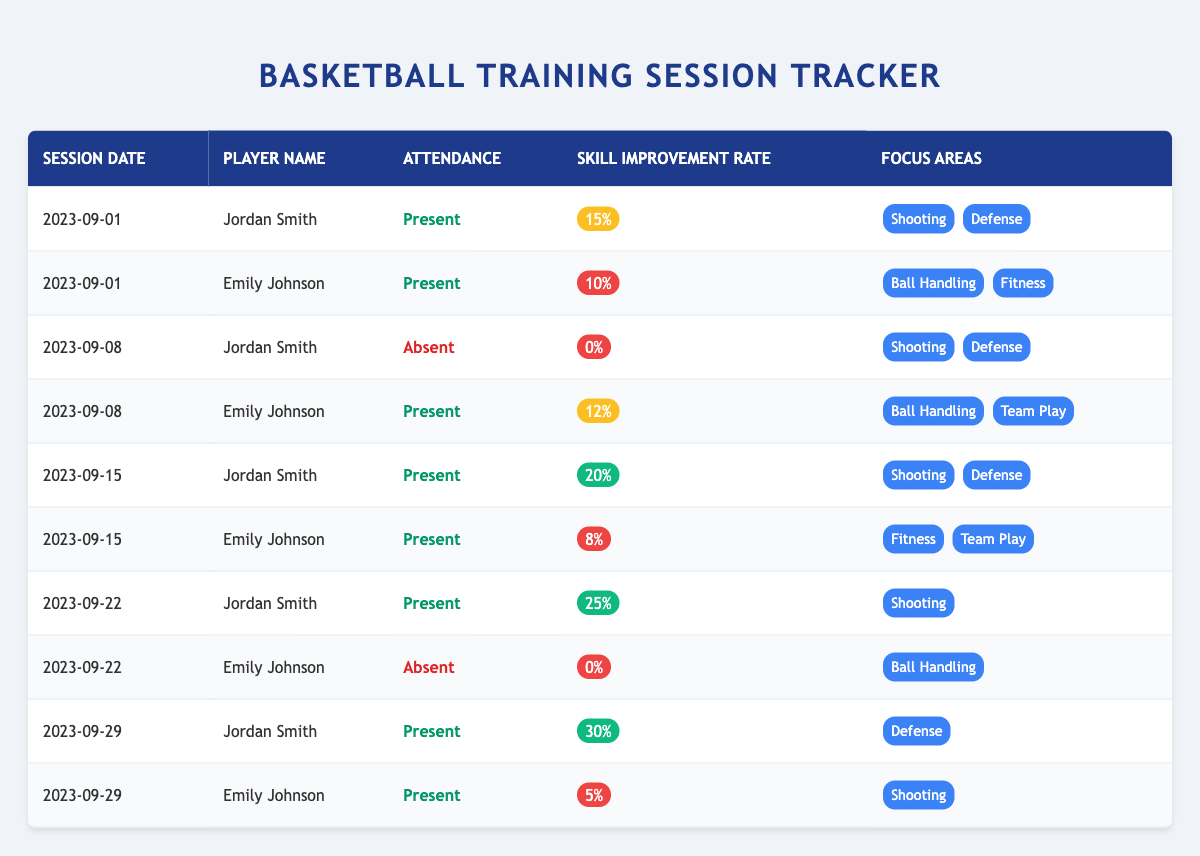What percentage improvement did Jordan Smith achieve on September 15? On September 15, Jordan Smith's skill improvement rate is listed as 20%.
Answer: 20% How many training sessions did Emily Johnson attend? Emily Johnson attended sessions on September 1, September 8, September 15, and September 29, which totals 4 sessions.
Answer: 4 What was the highest skill improvement rate recorded by Jordan Smith? The highest improvement rate reported for Jordan Smith is 30% on September 29.
Answer: 30% Did Emily Johnson show any improvement on September 22? On September 22, Emily Johnson had a skill improvement rate of 0%, indicating no improvement.
Answer: No What was the average skill improvement rate for Jordan Smith during the sessions he attended? Jordan Smith's rates are 15%, 20%, 25%, and 30%. The sum is 90%, divided by 4 sessions gives an average of 22.5%.
Answer: 22.5% How many focus areas did Jordan Smith work on overall? Jordan Smith worked on "Shooting" and "Defense" for sessions 1, 2, and 3, and focused on "Shooting" for session 4, and "Defense" in session 5. Total unique focus areas are "Shooting" and "Defense," which counts to 2 areas.
Answer: 2 What was the skill improvement rate for Emily Johnson on the last training session? On September 29, Emily Johnson's skill improvement rate is listed as 5%.
Answer: 5% What was the average skill improvement rate for Emily Johnson over the sessions she attended? Emily Johnson's improvement rates are 10%, 12%, 8%, and 5%. The sum is 35%, divided by 4 sessions gives an average of 8.75%.
Answer: 8.75% Did either player achieve an improvement rate of 0% more than once? Yes, Emily Johnson had an improvement rate of 0% on September 22, and Jordan Smith had an improvement rate of 0% on September 8, but it was not recorded for either player more than once.
Answer: Yes How many sessions had Jordan Smith as present? Jordan Smith was present on September 1, September 15, September 22, and September 29, resulting in a total of 4 sessions attended.
Answer: 4 What is the difference in skill improvement rate between the highest recorded for Jordan Smith and Emily Johnson? Jordan Smith's highest rate is 30% and Emily Johnson's highest is 12%. The difference is 30% - 12% = 18%.
Answer: 18% 